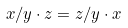Convert formula to latex. <formula><loc_0><loc_0><loc_500><loc_500>x / y \cdot z = z / y \cdot x</formula> 